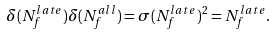<formula> <loc_0><loc_0><loc_500><loc_500>\delta ( N _ { f } ^ { l a t e } ) \delta ( N _ { f } ^ { a l l } ) = \sigma ( N _ { f } ^ { l a t e } ) ^ { 2 } = N _ { f } ^ { l a t e } .</formula> 